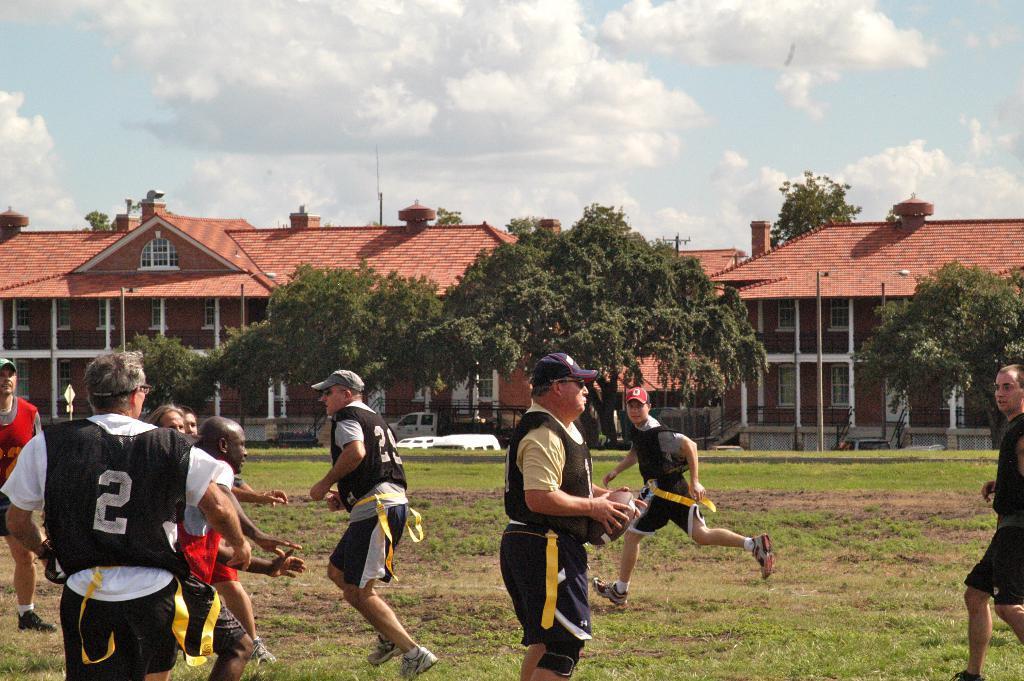Please provide a concise description of this image. In the image I can see the ground, some grass on the ground and few persons are standing on the ground. In the background I can see few buildings, few trees, few poles, few vehicles and the sky. 